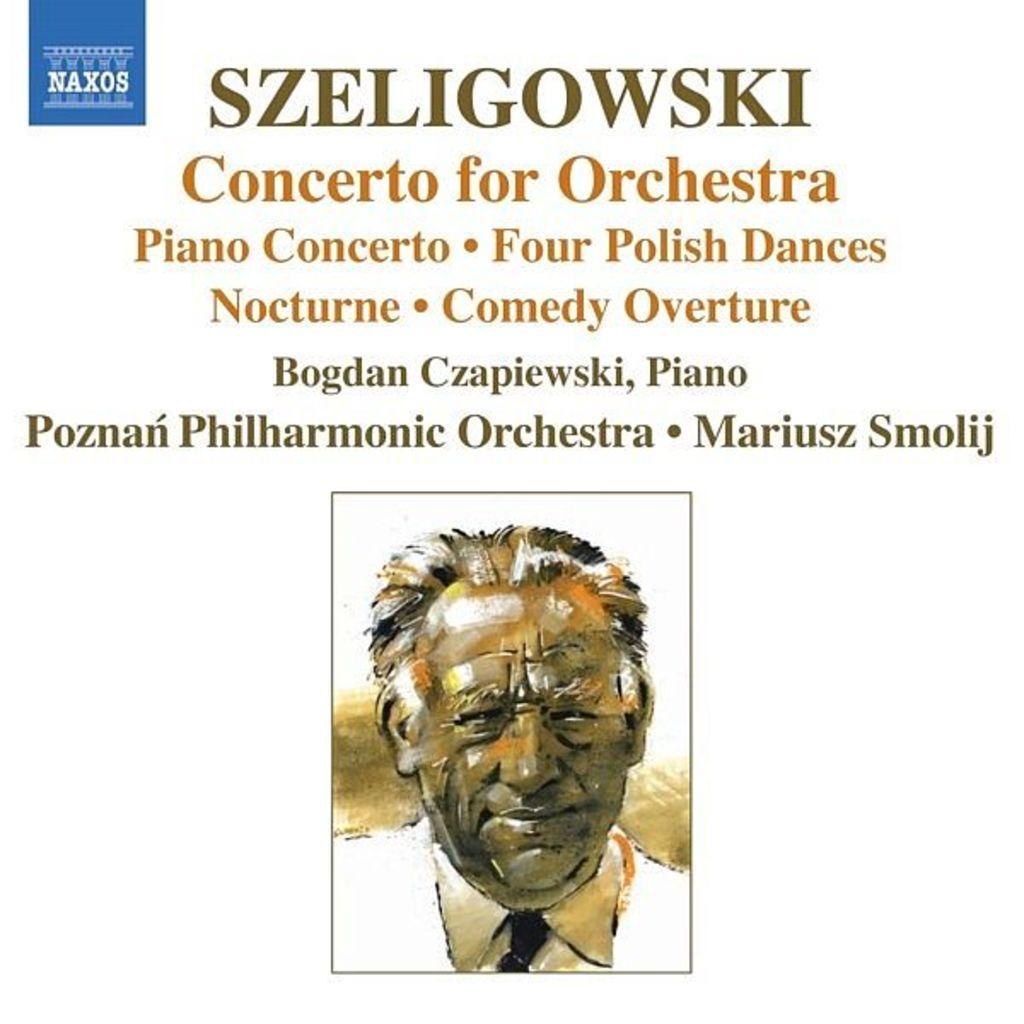Could you give a brief overview of what you see in this image? There is a picture of a person and there is something written above it. 